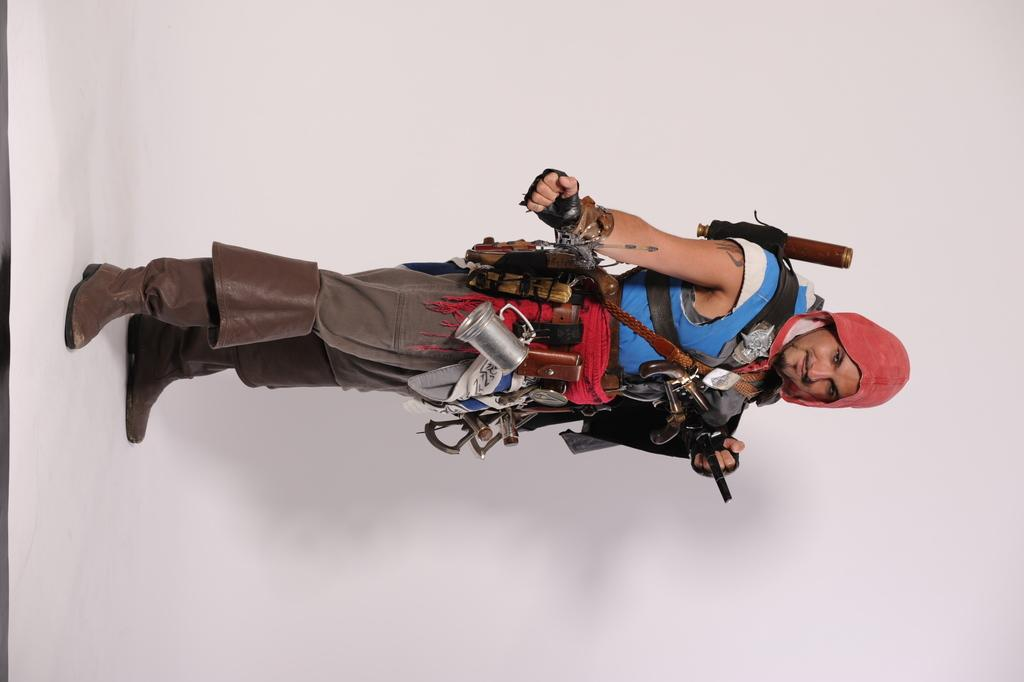What is the primary subject of the image? There is a person in the image. What is the person doing in the image? The person is standing. What is the person holding or carrying in the image? The person is carrying objects. What type of basin can be seen in the image? There is no basin present in the image. What word is being spoken by the person in the image? The image does not provide any information about the person speaking or any words being spoken. 